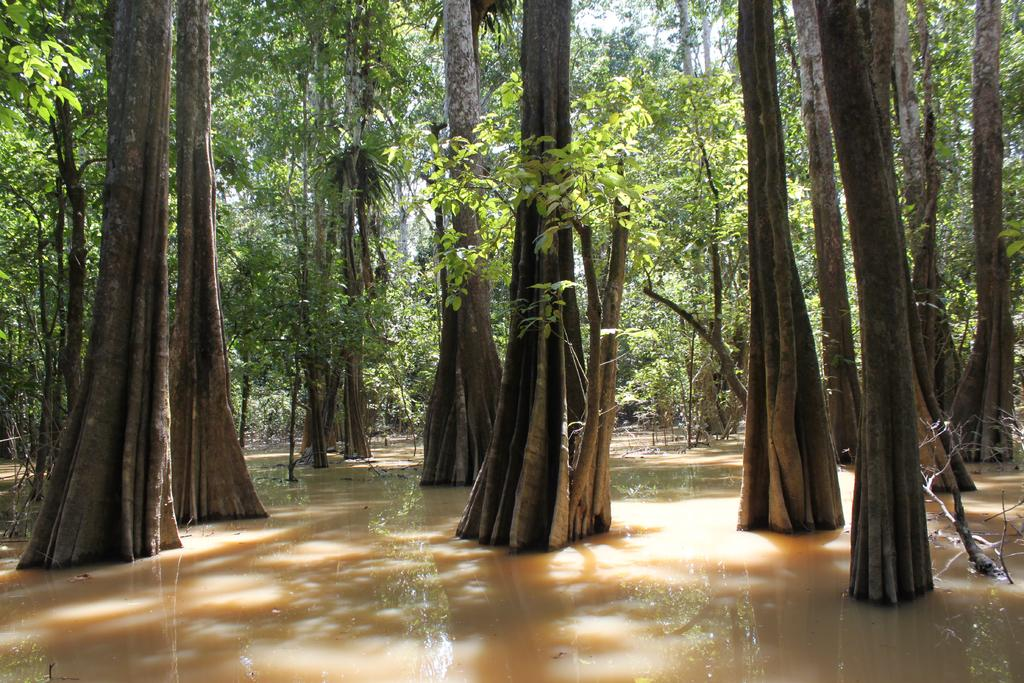What is visible in the image? Water and trees are visible in the image. Can you describe the water in the image? The water is visible, but its specific characteristics are not mentioned in the provided facts. What type of vegetation is present in the image? Trees are present in the image. What type of plant is shown growing on the trees in the image? There is no specific plant mentioned as growing on the trees in the image. What historical event is depicted in the image? There is no historical event depicted in the image; it features water and trees. 